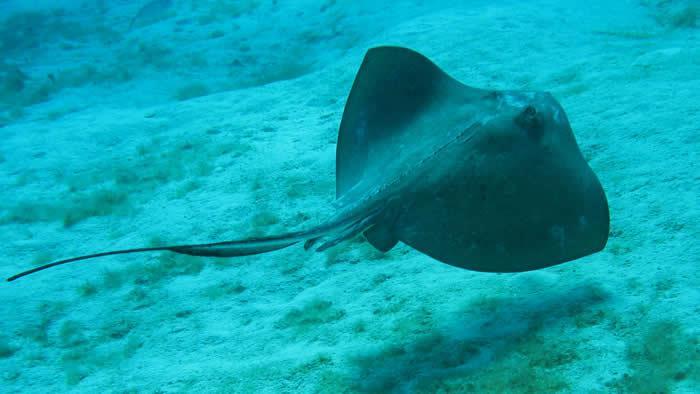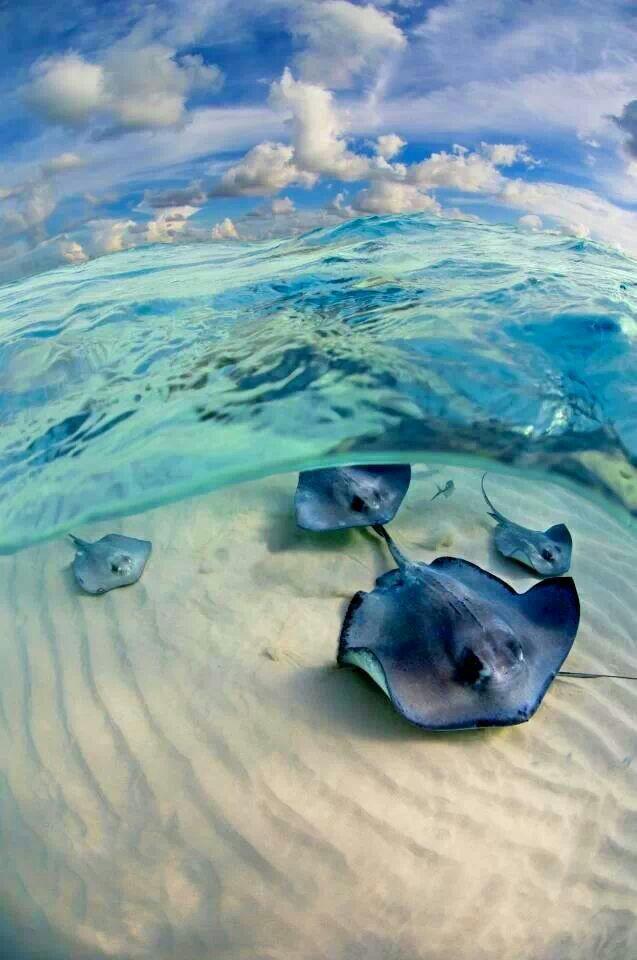The first image is the image on the left, the second image is the image on the right. Analyze the images presented: Is the assertion "There are at least two rays in at least one of the images." valid? Answer yes or no. Yes. The first image is the image on the left, the second image is the image on the right. Examine the images to the left and right. Is the description "The underside of a stingray, including its mouth, is visible in the right-hand image." accurate? Answer yes or no. No. 